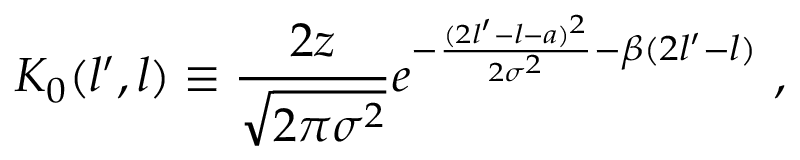Convert formula to latex. <formula><loc_0><loc_0><loc_500><loc_500>K _ { 0 } ( l ^ { \prime } , l ) \equiv \frac { 2 z } { \sqrt { 2 \pi \sigma ^ { 2 } } } e ^ { - \frac { ( 2 l ^ { \prime } - l - a ) ^ { 2 } } { 2 \sigma ^ { 2 } } - \beta ( 2 l ^ { \prime } - l ) } \ ,</formula> 